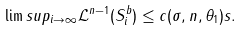<formula> <loc_0><loc_0><loc_500><loc_500>\lim s u p _ { i \rightarrow \infty } { \mathcal { L } } ^ { n - 1 } ( S _ { i } ^ { b } ) \leq c ( \sigma , n , \theta _ { 1 } ) s .</formula> 